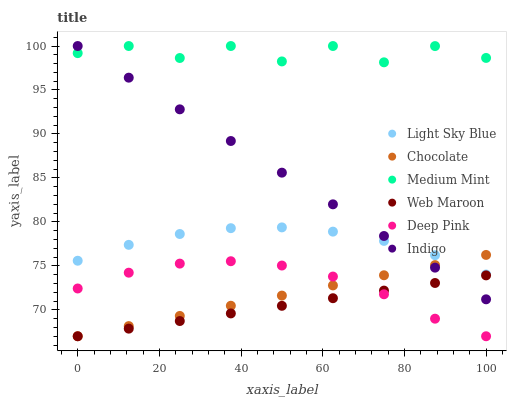Does Web Maroon have the minimum area under the curve?
Answer yes or no. Yes. Does Medium Mint have the maximum area under the curve?
Answer yes or no. Yes. Does Deep Pink have the minimum area under the curve?
Answer yes or no. No. Does Deep Pink have the maximum area under the curve?
Answer yes or no. No. Is Indigo the smoothest?
Answer yes or no. Yes. Is Medium Mint the roughest?
Answer yes or no. Yes. Is Deep Pink the smoothest?
Answer yes or no. No. Is Deep Pink the roughest?
Answer yes or no. No. Does Deep Pink have the lowest value?
Answer yes or no. Yes. Does Indigo have the lowest value?
Answer yes or no. No. Does Indigo have the highest value?
Answer yes or no. Yes. Does Deep Pink have the highest value?
Answer yes or no. No. Is Web Maroon less than Light Sky Blue?
Answer yes or no. Yes. Is Medium Mint greater than Deep Pink?
Answer yes or no. Yes. Does Indigo intersect Chocolate?
Answer yes or no. Yes. Is Indigo less than Chocolate?
Answer yes or no. No. Is Indigo greater than Chocolate?
Answer yes or no. No. Does Web Maroon intersect Light Sky Blue?
Answer yes or no. No. 